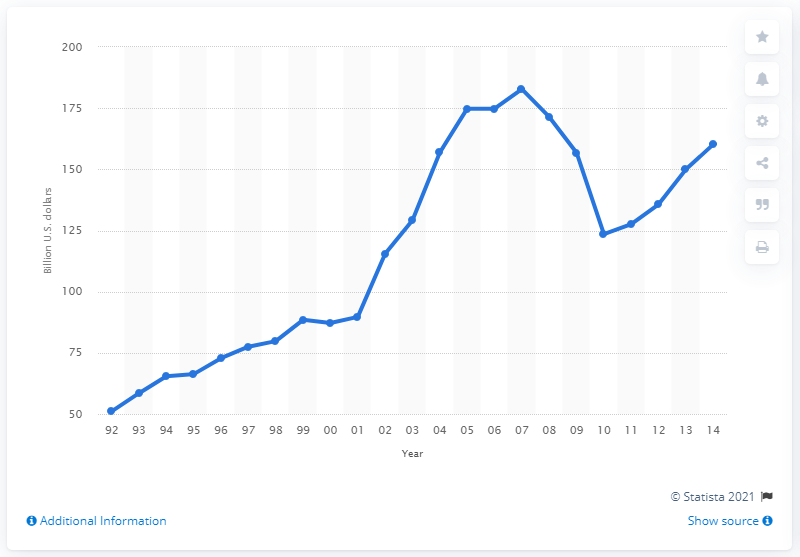Specify some key components in this picture. In 2009, U.S. merchant wholesalers sold a total of $123.5 million worth of lumber and construction materials. In 2009, the sales of lumber and construction materials by U.S. merchant wholesalers totaled 123.5 million dollars. 